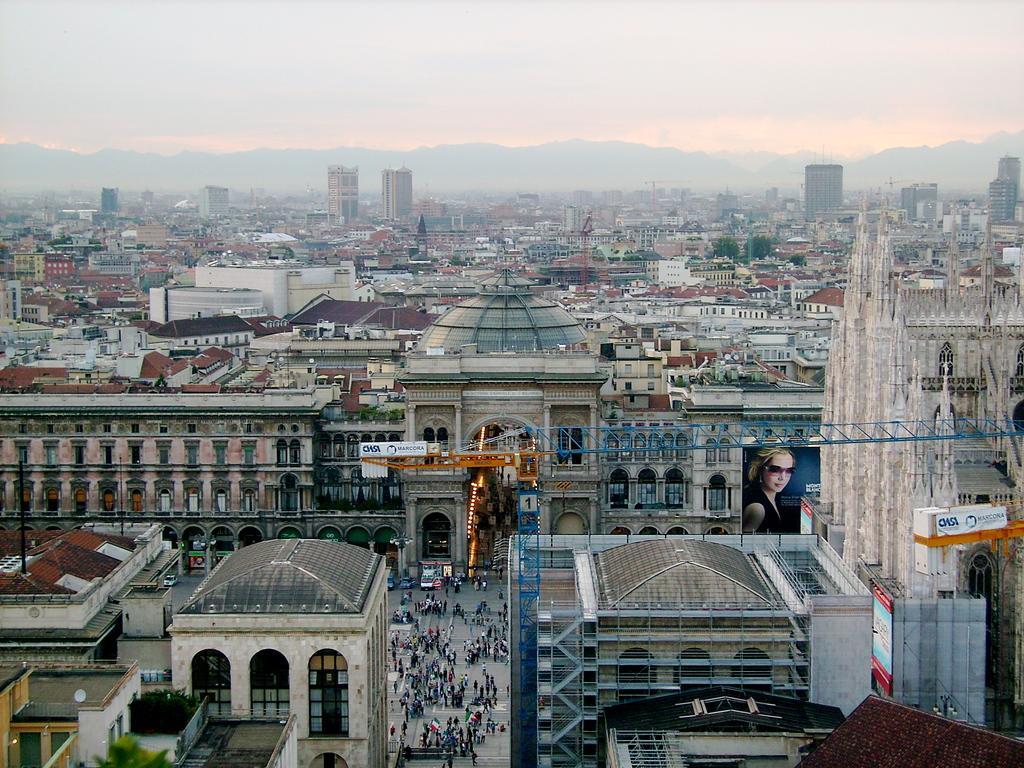Can you describe this image briefly? In this image I can see group of people some are standing and some are walking. Background I can see few buildings, they are in brown, white, cream color and the sky is in white color. 